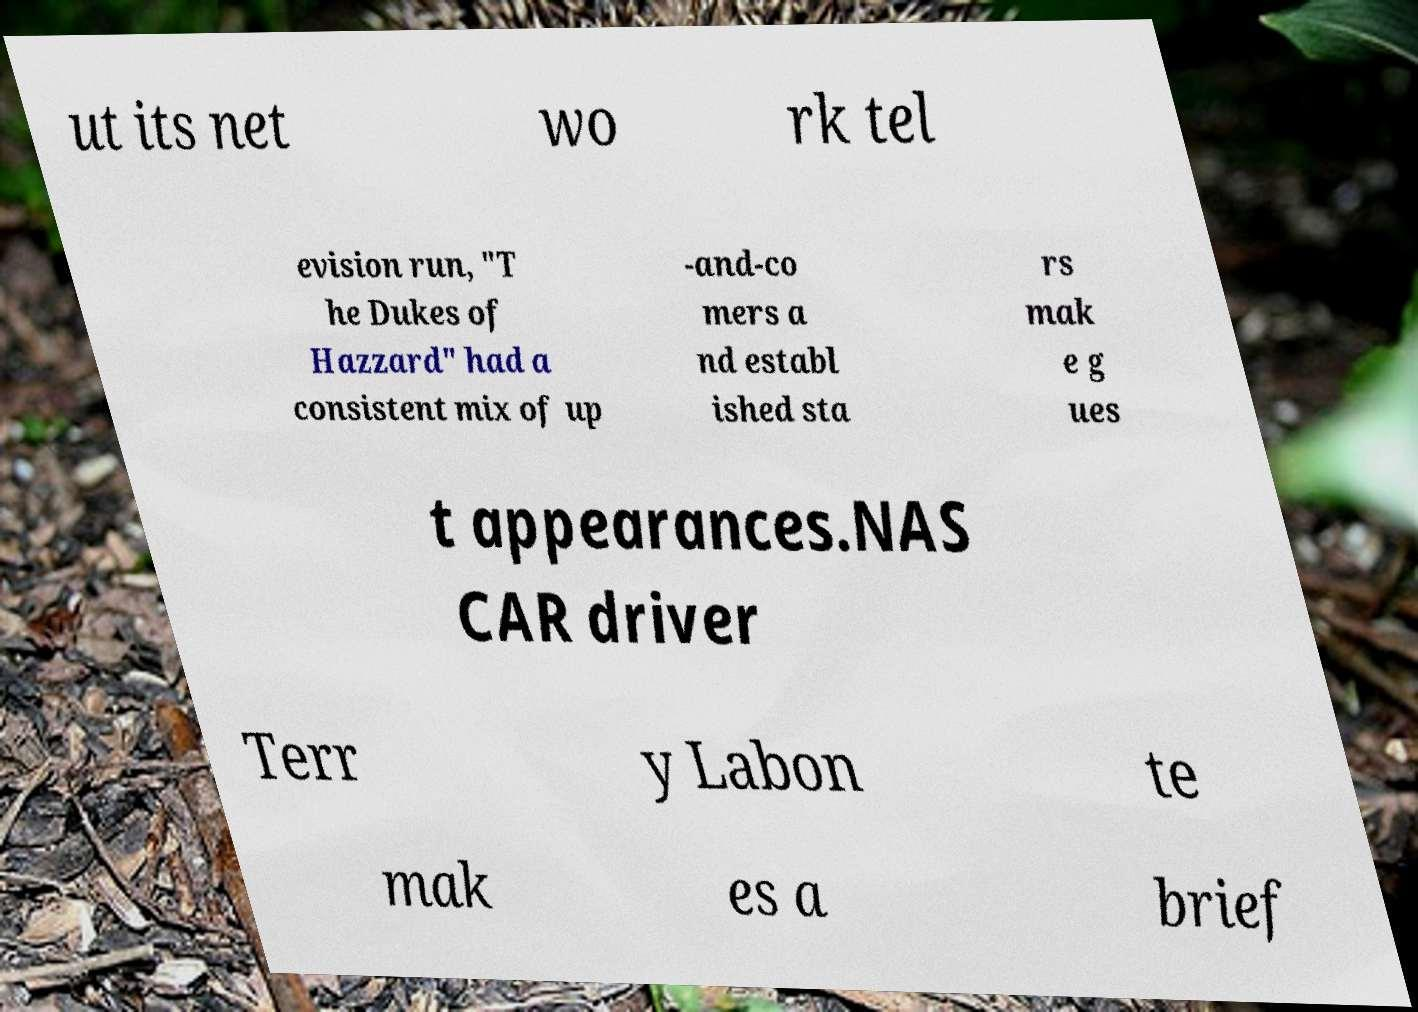Could you assist in decoding the text presented in this image and type it out clearly? ut its net wo rk tel evision run, "T he Dukes of Hazzard" had a consistent mix of up -and-co mers a nd establ ished sta rs mak e g ues t appearances.NAS CAR driver Terr y Labon te mak es a brief 